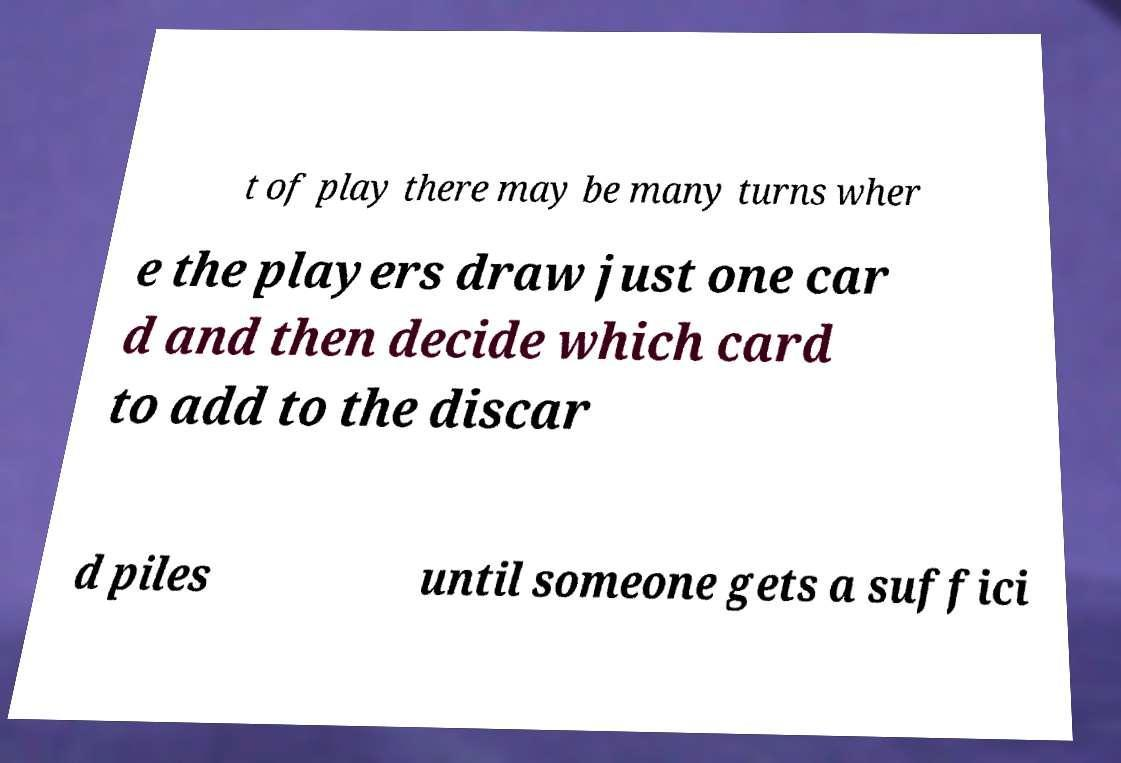Could you assist in decoding the text presented in this image and type it out clearly? t of play there may be many turns wher e the players draw just one car d and then decide which card to add to the discar d piles until someone gets a suffici 